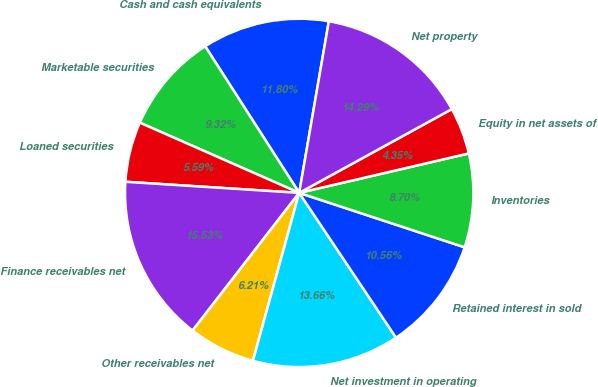Convert chart to OTSL. <chart><loc_0><loc_0><loc_500><loc_500><pie_chart><fcel>Cash and cash equivalents<fcel>Marketable securities<fcel>Loaned securities<fcel>Finance receivables net<fcel>Other receivables net<fcel>Net investment in operating<fcel>Retained interest in sold<fcel>Inventories<fcel>Equity in net assets of<fcel>Net property<nl><fcel>11.8%<fcel>9.32%<fcel>5.59%<fcel>15.53%<fcel>6.21%<fcel>13.66%<fcel>10.56%<fcel>8.7%<fcel>4.35%<fcel>14.29%<nl></chart> 